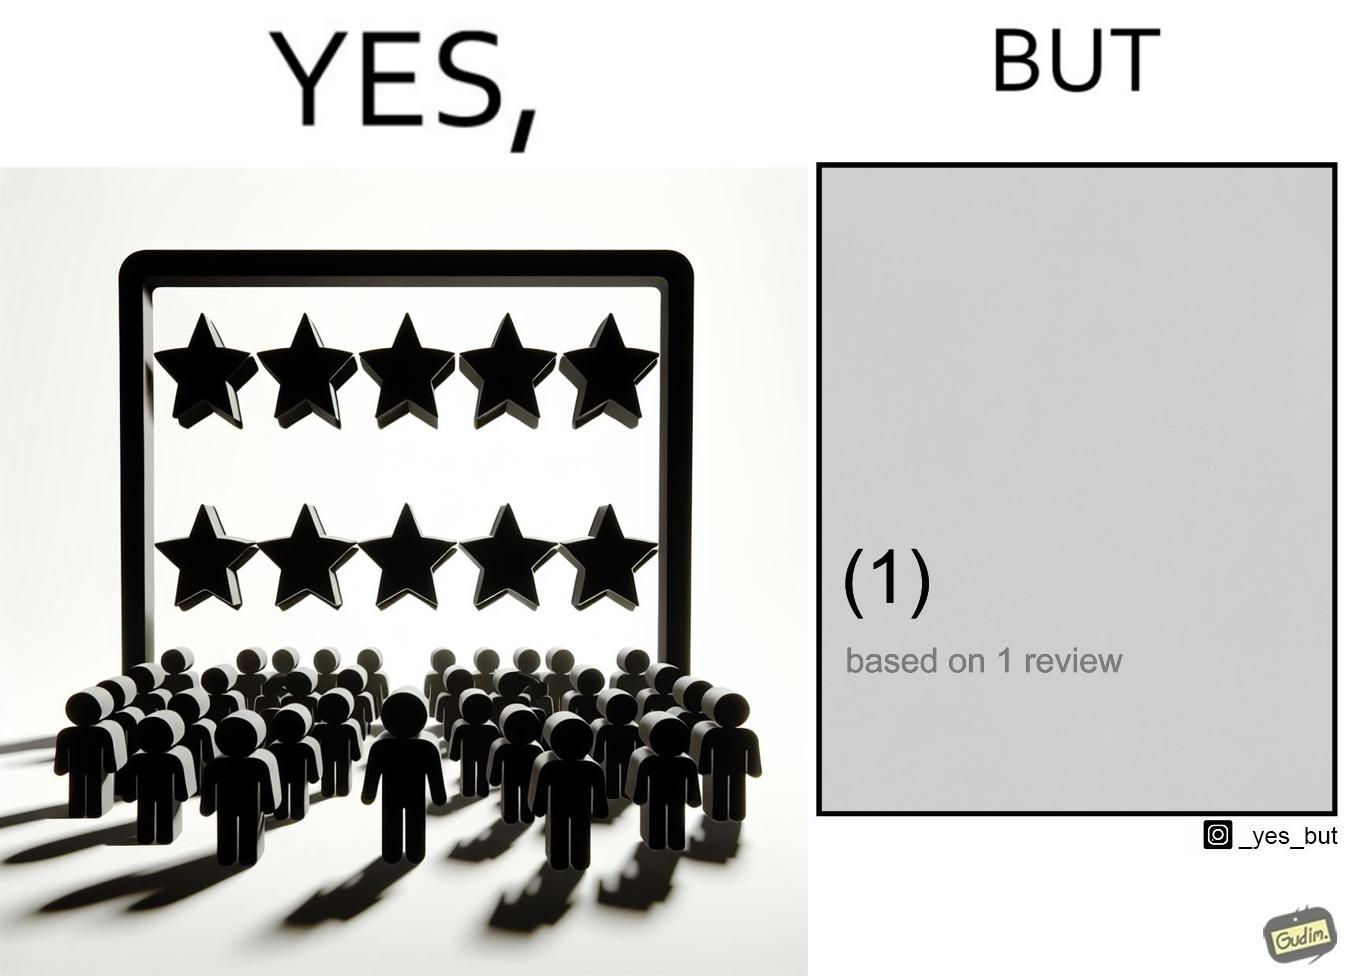What does this image depict? The image is ironical, as a product/service is rated 5 out of 5 stars, but it has only 1 review, and hence, this rating might actually be misleading. 